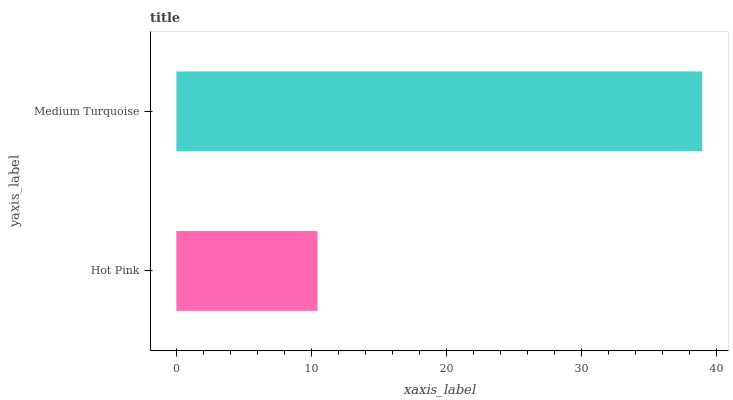Is Hot Pink the minimum?
Answer yes or no. Yes. Is Medium Turquoise the maximum?
Answer yes or no. Yes. Is Medium Turquoise the minimum?
Answer yes or no. No. Is Medium Turquoise greater than Hot Pink?
Answer yes or no. Yes. Is Hot Pink less than Medium Turquoise?
Answer yes or no. Yes. Is Hot Pink greater than Medium Turquoise?
Answer yes or no. No. Is Medium Turquoise less than Hot Pink?
Answer yes or no. No. Is Medium Turquoise the high median?
Answer yes or no. Yes. Is Hot Pink the low median?
Answer yes or no. Yes. Is Hot Pink the high median?
Answer yes or no. No. Is Medium Turquoise the low median?
Answer yes or no. No. 